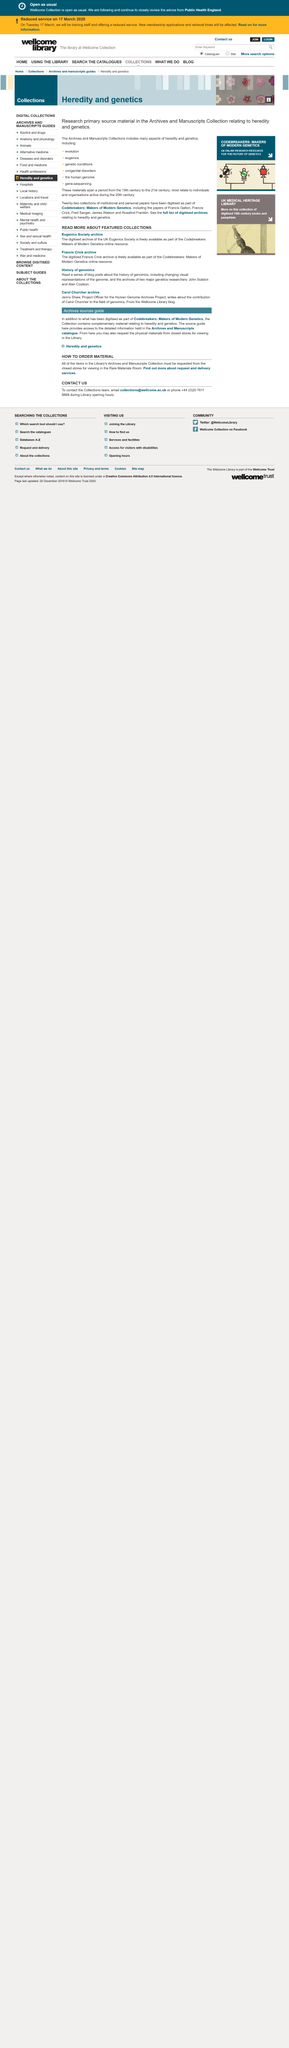Mention a couple of crucial points in this snapshot. There are three featured collections. John Sulston and Alan Coulson are two prominent genetics researchers who have made significant contributions to the history of genomics. The digitized Frances Crick archive is freely available as part of Codebreakers. 